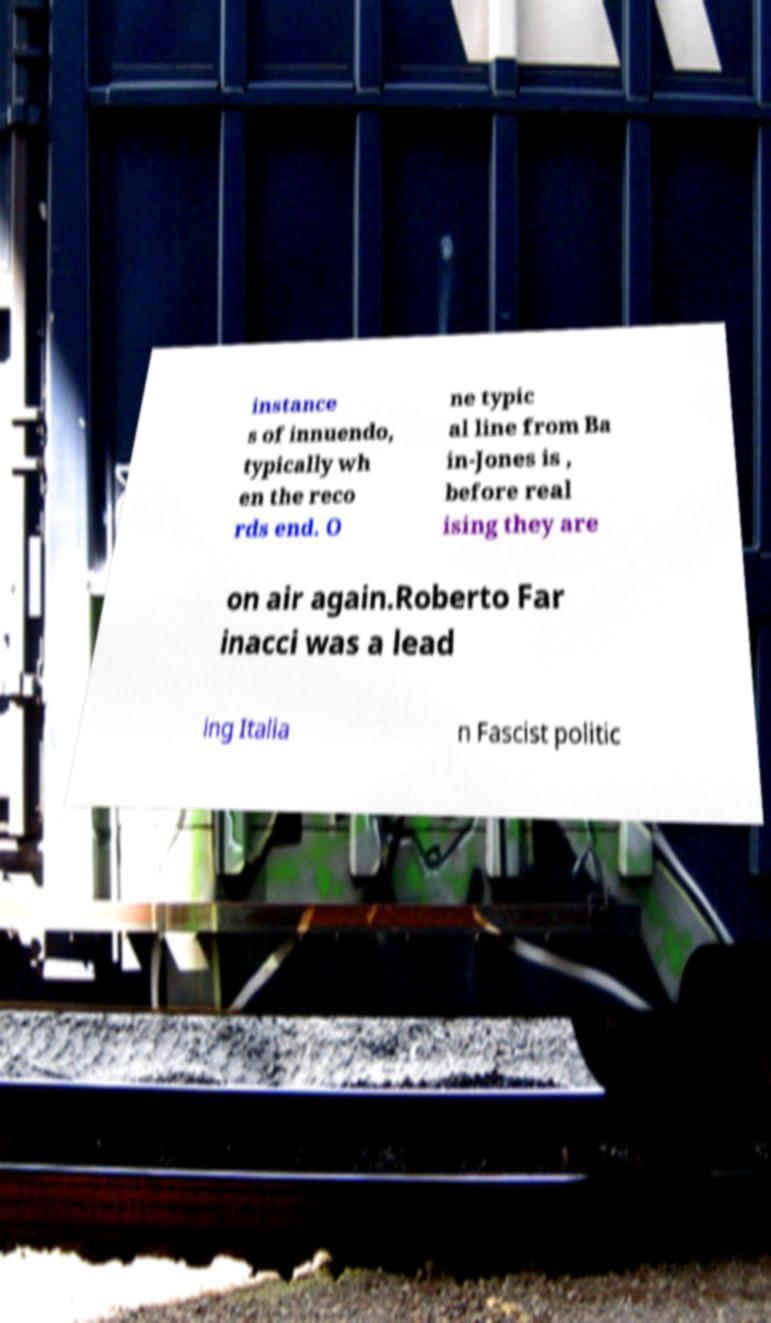Please identify and transcribe the text found in this image. instance s of innuendo, typically wh en the reco rds end. O ne typic al line from Ba in-Jones is , before real ising they are on air again.Roberto Far inacci was a lead ing Italia n Fascist politic 